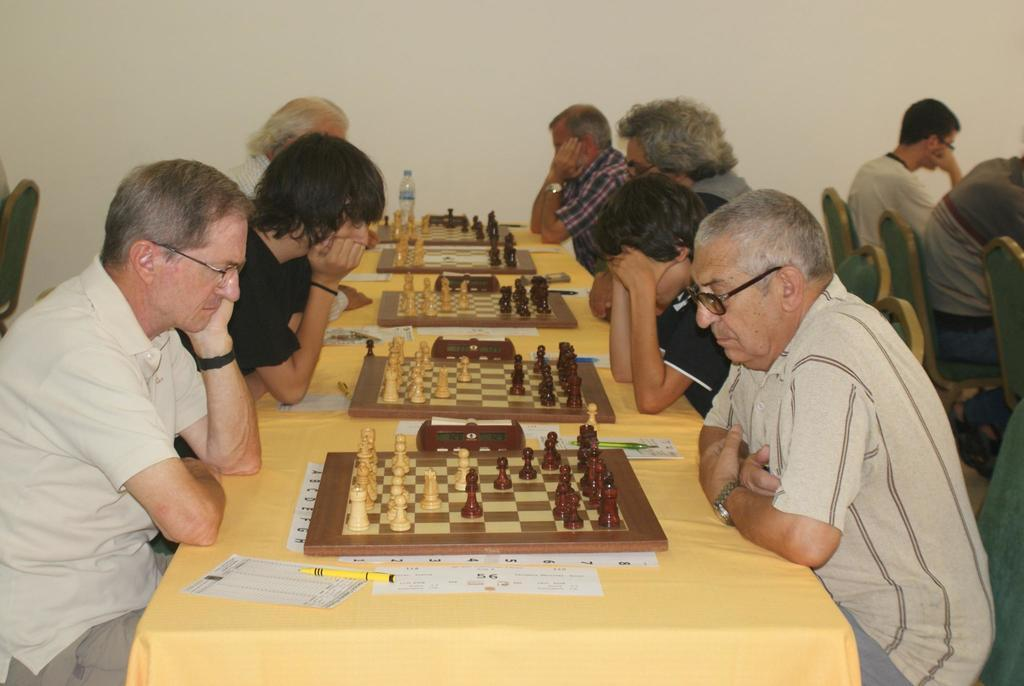How many people are in the image? There is a group of people in the image. What are the people doing in the image? The people are sitting on chairs. What can be seen on the table in the image? There is a chess board and a paper on the table. What else is on the table in the image? There is a pen on the table. What type of nest can be seen in the image? There is no nest present in the image. How much money is on the table in the image? There is no money present in the image. 